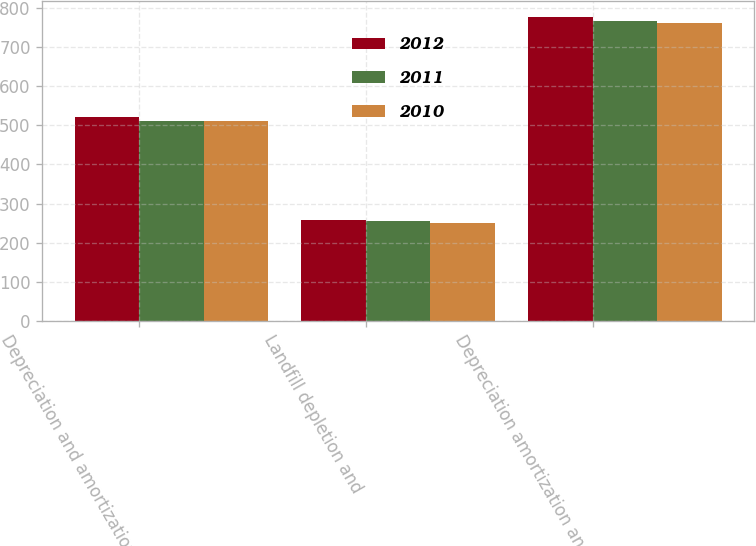Convert chart to OTSL. <chart><loc_0><loc_0><loc_500><loc_500><stacked_bar_chart><ecel><fcel>Depreciation and amortization<fcel>Landfill depletion and<fcel>Depreciation amortization and<nl><fcel>2012<fcel>520.8<fcel>257.6<fcel>778.4<nl><fcel>2011<fcel>511.4<fcel>255.5<fcel>766.9<nl><fcel>2010<fcel>511.6<fcel>250.6<fcel>762.2<nl></chart> 